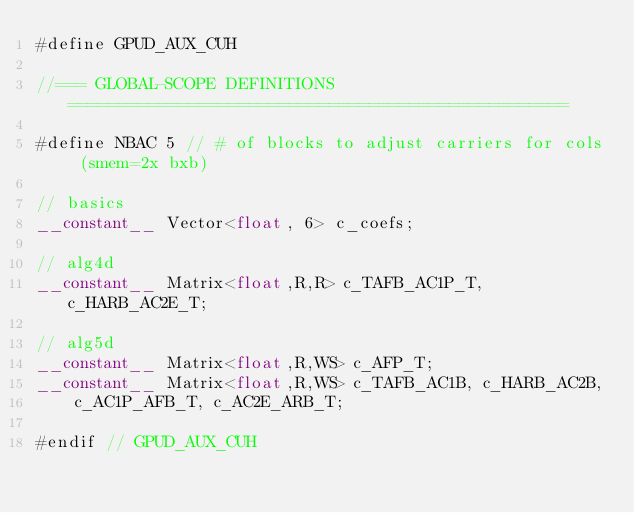Convert code to text. <code><loc_0><loc_0><loc_500><loc_500><_Cuda_>#define GPUD_AUX_CUH

//=== GLOBAL-SCOPE DEFINITIONS ==================================================

#define NBAC 5 // # of blocks to adjust carriers for cols (smem=2x bxb)

// basics
__constant__ Vector<float, 6> c_coefs;

// alg4d
__constant__ Matrix<float,R,R> c_TAFB_AC1P_T, c_HARB_AC2E_T;

// alg5d
__constant__ Matrix<float,R,WS> c_AFP_T;
__constant__ Matrix<float,R,WS> c_TAFB_AC1B, c_HARB_AC2B,
    c_AC1P_AFB_T, c_AC2E_ARB_T;

#endif // GPUD_AUX_CUH
</code> 